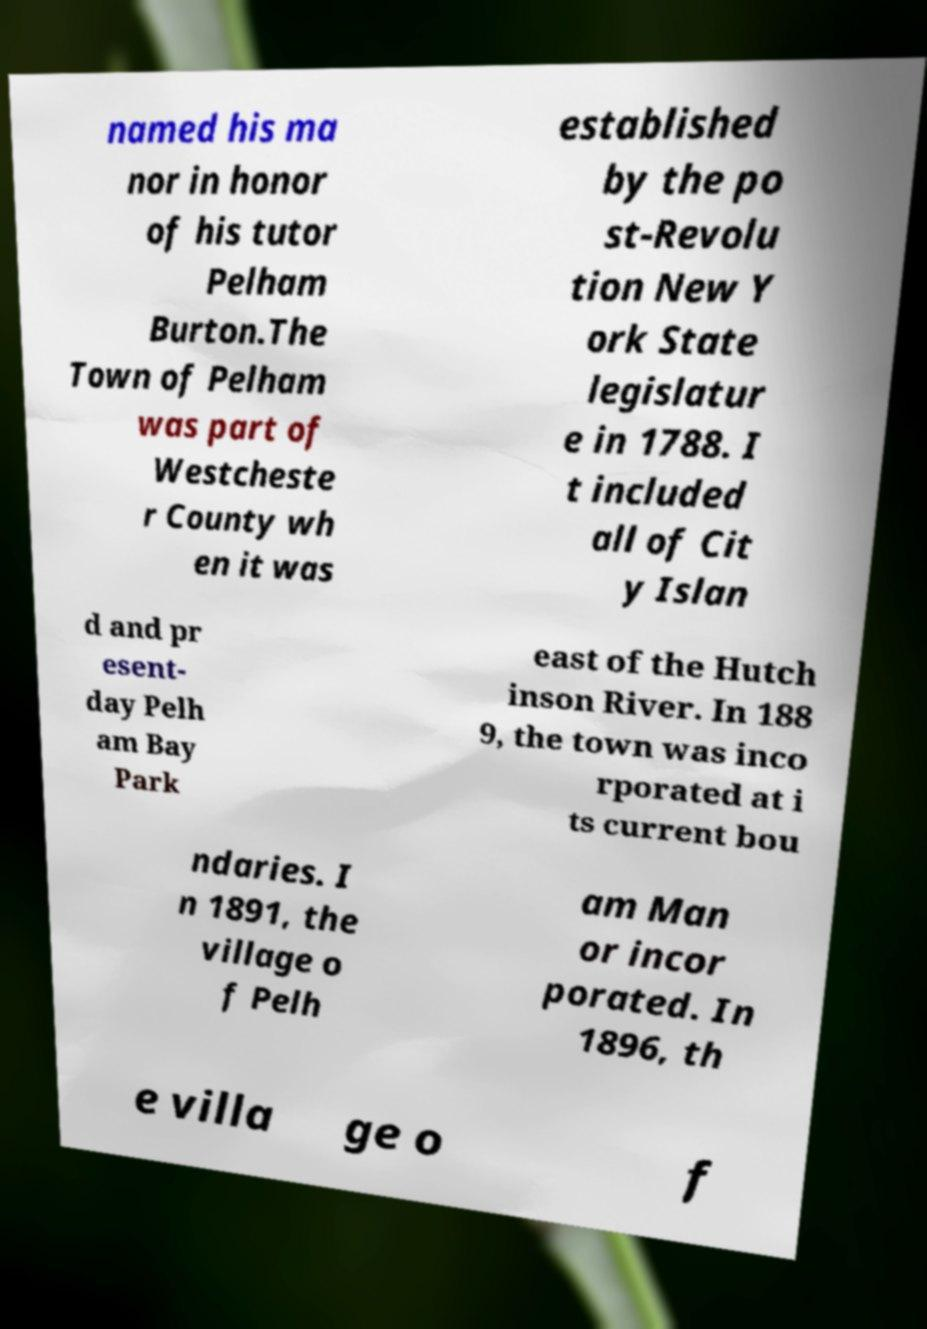What messages or text are displayed in this image? I need them in a readable, typed format. named his ma nor in honor of his tutor Pelham Burton.The Town of Pelham was part of Westcheste r County wh en it was established by the po st-Revolu tion New Y ork State legislatur e in 1788. I t included all of Cit y Islan d and pr esent- day Pelh am Bay Park east of the Hutch inson River. In 188 9, the town was inco rporated at i ts current bou ndaries. I n 1891, the village o f Pelh am Man or incor porated. In 1896, th e villa ge o f 